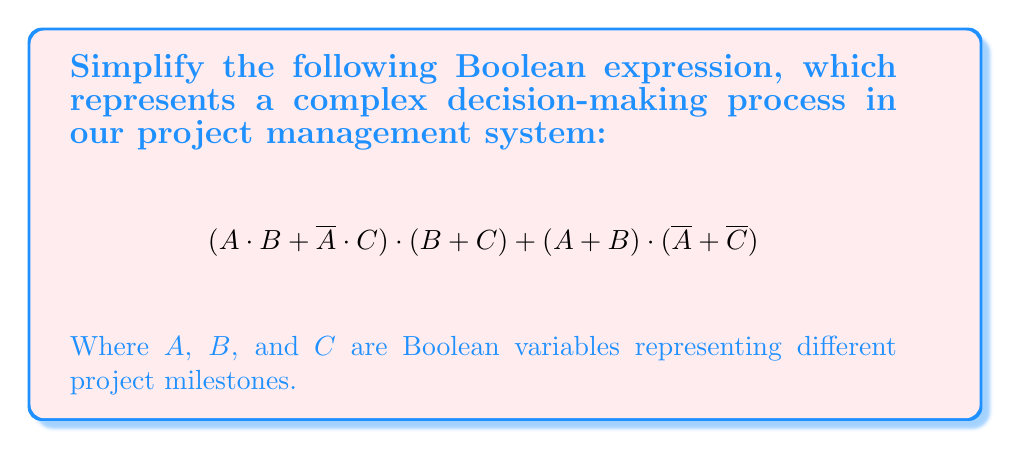Can you solve this math problem? Let's simplify this expression step-by-step using Boolean algebra laws:

1) First, let's apply the distributive law to the first term:
   $(A \cdot B + \overline{A} \cdot C) \cdot (B + C)$
   $= A \cdot B \cdot B + A \cdot B \cdot C + \overline{A} \cdot C \cdot B + \overline{A} \cdot C \cdot C$

2) Simplify using idempotent law ($X \cdot X = X$):
   $= A \cdot B + A \cdot B \cdot C + \overline{A} \cdot C \cdot B + \overline{A} \cdot C$

3) Now, let's simplify the second term $(A + B) \cdot (\overline{A} + \overline{C})$:
   $= A \cdot \overline{A} + A \cdot \overline{C} + B \cdot \overline{A} + B \cdot \overline{C}$

4) Simplify using complement law ($X \cdot \overline{X} = 0$):
   $= A \cdot \overline{C} + B \cdot \overline{A} + B \cdot \overline{C}$

5) Now our expression looks like:
   $(A \cdot B + A \cdot B \cdot C + \overline{A} \cdot C \cdot B + \overline{A} \cdot C) + (A \cdot \overline{C} + B \cdot \overline{A} + B \cdot \overline{C})$

6) Combine like terms:
   $A \cdot B + A \cdot B \cdot C + \overline{A} \cdot C \cdot B + \overline{A} \cdot C + A \cdot \overline{C} + B \cdot \overline{A} + B \cdot \overline{C}$

7) Apply absorption law ($X + X \cdot Y = X$) to $A \cdot B + A \cdot B \cdot C$:
   $A \cdot B + \overline{A} \cdot C \cdot B + \overline{A} \cdot C + A \cdot \overline{C} + B \cdot \overline{A} + B \cdot \overline{C}$

8) Apply consensus theorem ($X \cdot Y + \overline{X} \cdot Z + Y \cdot Z = X \cdot Y + \overline{X} \cdot Z$) to $A \cdot B + \overline{A} \cdot C + B \cdot C$:
   $A \cdot B + \overline{A} \cdot C + A \cdot \overline{C} + B \cdot \overline{A} + B \cdot \overline{C}$

9) This is our final simplified form, which cannot be reduced further.
Answer: $A \cdot B + \overline{A} \cdot C + A \cdot \overline{C} + B \cdot \overline{A} + B \cdot \overline{C}$ 